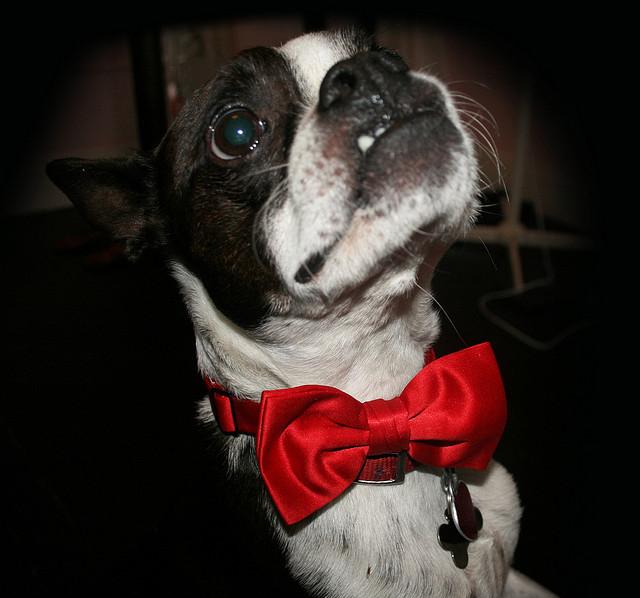Does this dog have an owner?
Short answer required. Yes. Is this dog ready for a party?
Quick response, please. Yes. What is the dog wearing?
Keep it brief. Bow tie. 